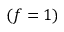Convert formula to latex. <formula><loc_0><loc_0><loc_500><loc_500>( f = 1 )</formula> 